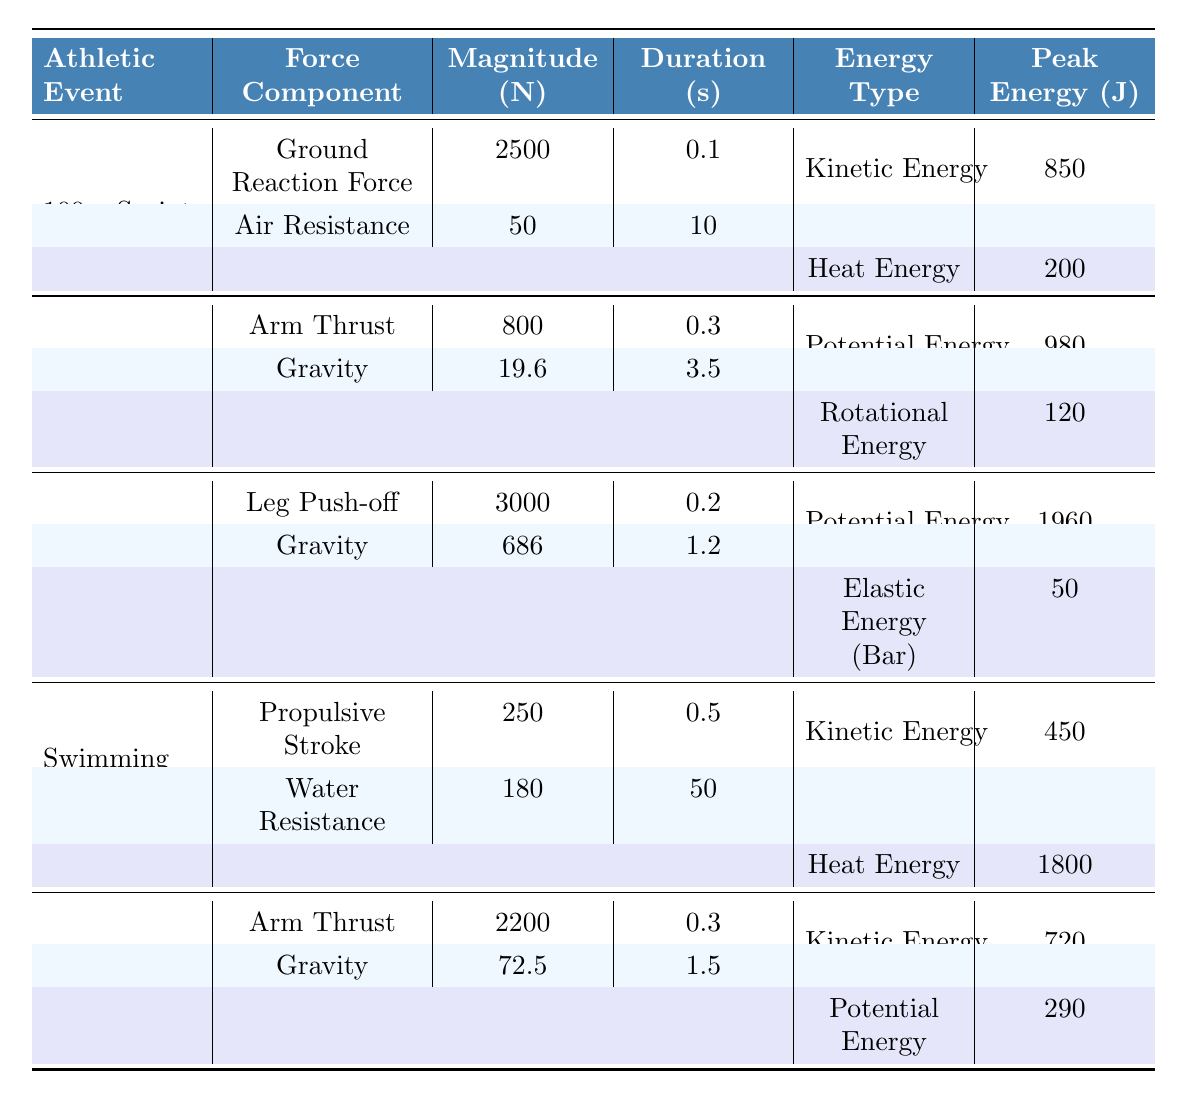What is the magnitude of the ground reaction force in the 100m sprint? According to the table for the 100m sprint, the force component indicated as "Ground Reaction Force" has a magnitude of 2500 N.
Answer: 2500 N What type of energy is associated with the Javelin throw that has a peak value of 980 J? The table lists "Potential Energy" as the type associated with the Javelin throw that has a peak value of 980 J.
Answer: Potential Energy How long is the air resistance force applied during the 100m sprint? The duration for the "Air Resistance" force in the 100m sprint is stated in the table as 10 seconds.
Answer: 10 seconds Is the peak energy of the swimming event greater than the peak energy of the shot put event? The peak energy for swimming (450 J) is less than that of the shot put (720 J) as per the table. Therefore, the statement is false.
Answer: No What is the total duration of force application for the shot put event? For the shot put, the force components have durations of 0.3 seconds (Arm Thrust) and 1.5 seconds (Gravity). The total duration is 0.3 + 1.5 = 1.8 seconds.
Answer: 1.8 seconds Which events experience a force due to gravity, and what is that force's magnitude in each case? The "Javelin Throw" experiences a gravitational force of 19.6 N, and the "High Jump" experiences a gravitational force of 686 N, as listed in the respective sections of the table.
Answer: Javelin Throw: 19.6 N, High Jump: 686 N How much heat energy is dissipated during the swimming event? The table shows that the swimming event dissipates a total heat energy of 1800 J.
Answer: 1800 J What is the average peak energy between the high jump and shot put events? The peak energy for the high jump is 1960 J, and for the shot put, it is 720 J. The average is (1960 + 720) / 2 = 1290 J.
Answer: 1290 J Which athletic event has the highest peak energy and what type of energy is it? The high jump event has the highest peak energy at 1960 J, associated with "Potential Energy."
Answer: High Jump: 1960 J, Potential Energy What force component lasts the longest duration in the swimming event? The "Water Resistance" force lasts for 50 seconds, which is longer than the "Propulsive Stroke" force at 0.5 seconds.
Answer: Water Resistance, 50 seconds 